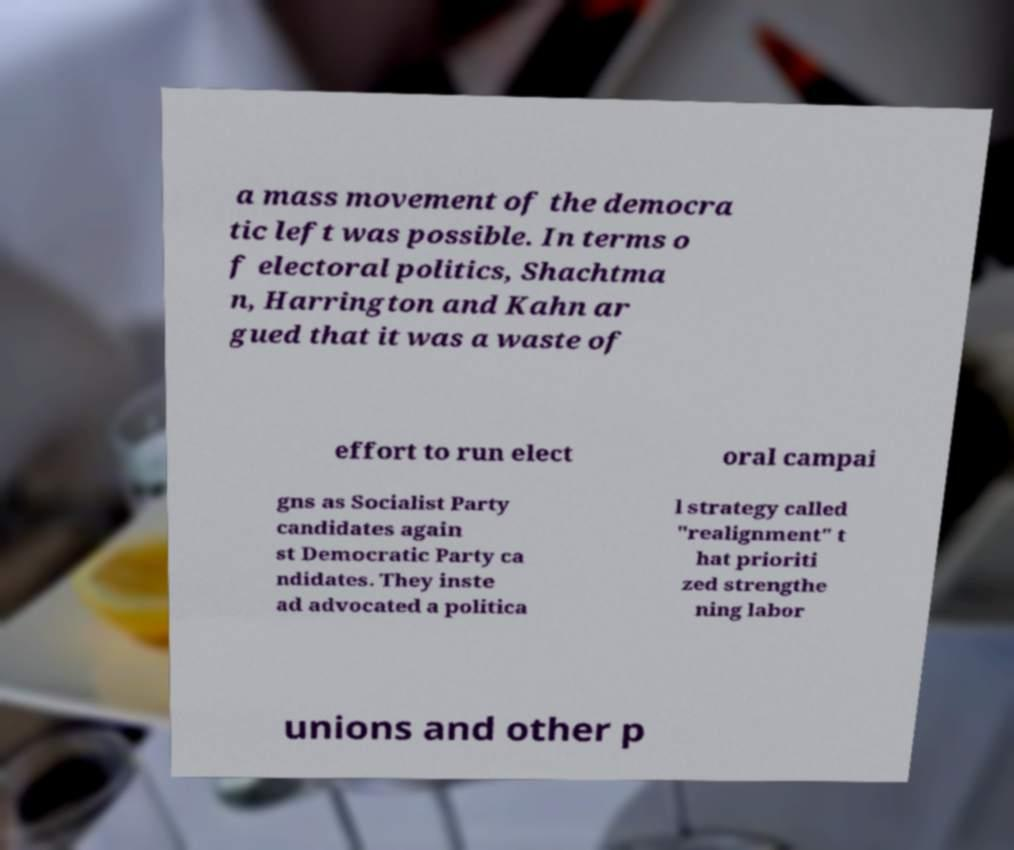Please read and relay the text visible in this image. What does it say? a mass movement of the democra tic left was possible. In terms o f electoral politics, Shachtma n, Harrington and Kahn ar gued that it was a waste of effort to run elect oral campai gns as Socialist Party candidates again st Democratic Party ca ndidates. They inste ad advocated a politica l strategy called "realignment" t hat prioriti zed strengthe ning labor unions and other p 